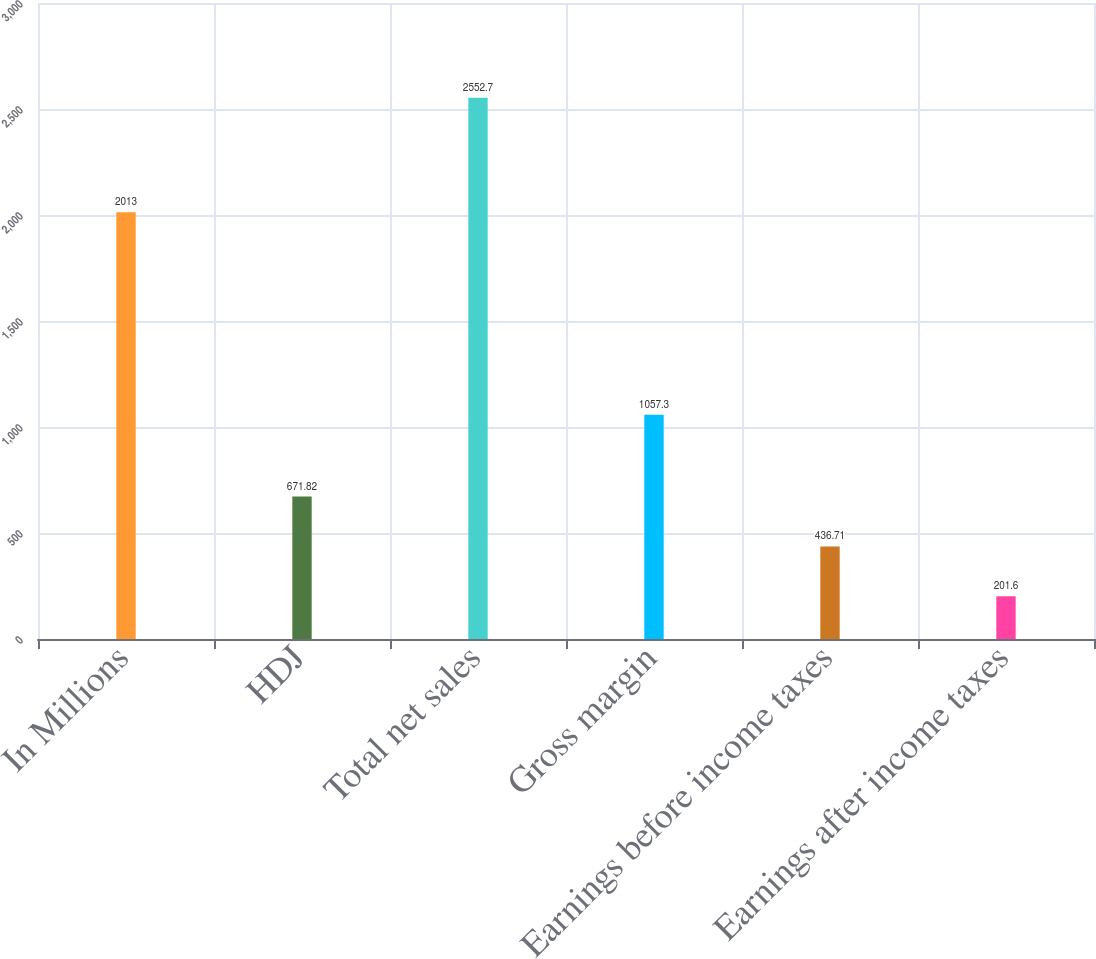Convert chart to OTSL. <chart><loc_0><loc_0><loc_500><loc_500><bar_chart><fcel>In Millions<fcel>HDJ<fcel>Total net sales<fcel>Gross margin<fcel>Earnings before income taxes<fcel>Earnings after income taxes<nl><fcel>2013<fcel>671.82<fcel>2552.7<fcel>1057.3<fcel>436.71<fcel>201.6<nl></chart> 